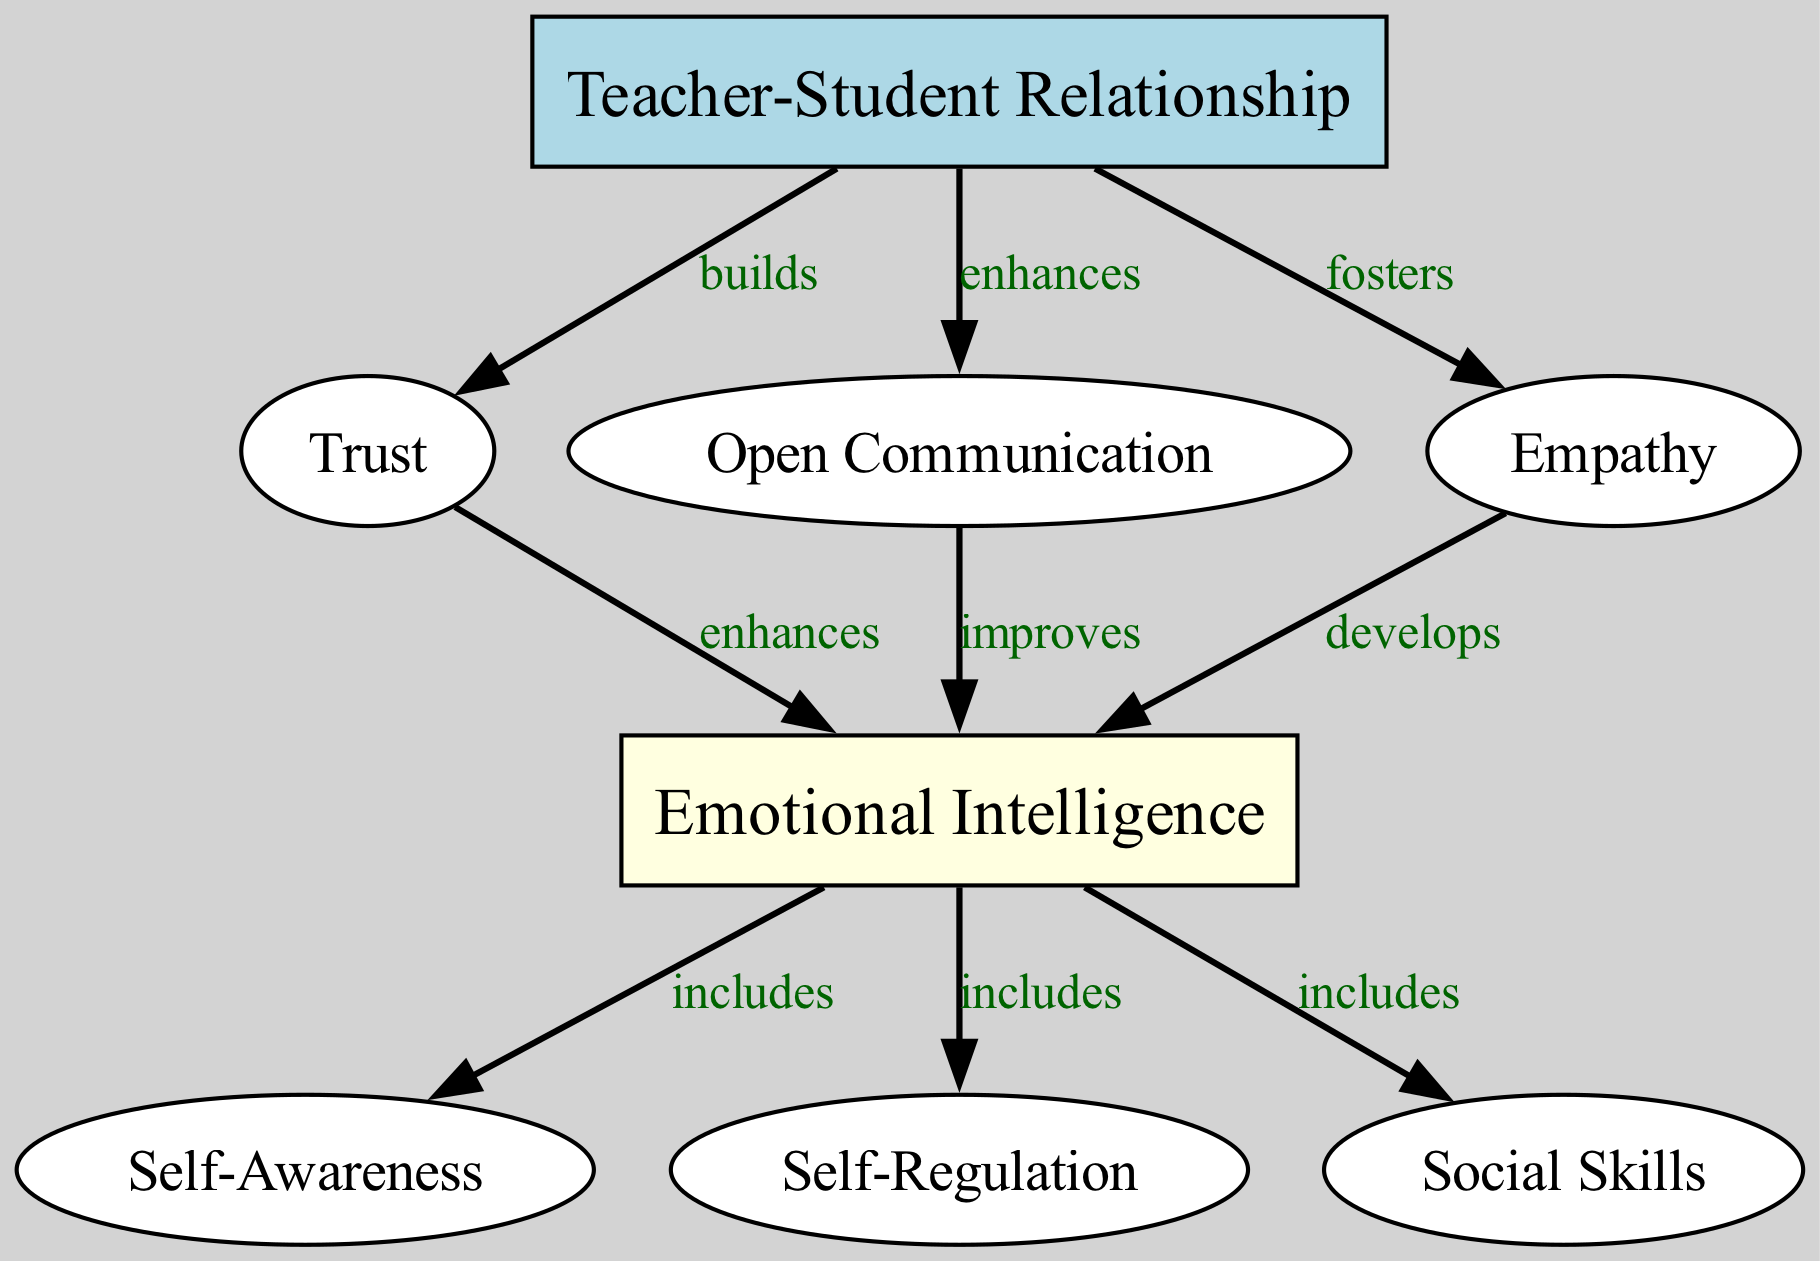What is the main influence depicted in the diagram that affects emotional intelligence? The diagram emphasizes the "Teacher-Student Relationship" as the primary influence since it is the root node, indicating that it is fundamental in fostering emotional intelligence through trust, communication, and empathy.
Answer: Teacher-Student Relationship How many nodes are present in the diagram? Counting all the nodes listed, there are eight distinct nodes displayed: Teacher-Student Relationship, Trust, Open Communication, Empathy, Emotional Intelligence, Self-Awareness, Self-Regulation, and Social Skills.
Answer: 8 Which node directly relates to trust? The node that is connected to trust is "emotional intelligence." The diagram shows that trust enhances emotional intelligence, indicating a direct relationship based on trust.
Answer: Emotional Intelligence What is the relationship between open communication and emotional intelligence? The diagram specifies that open communication "improves" emotional intelligence. This indicates that effective communication is a key factor contributing to better emotional intelligence in students.
Answer: Improves How does the diagram suggest that empathy affects emotional intelligence? According to the diagram, empathy "develops" emotional intelligence, meaning that fostering empathy in teacher-student relationships contributes to the growth of emotional intelligence in students.
Answer: Develops What three skills are included as part of emotional intelligence? The diagram shows that emotional intelligence includes self-awareness, self-regulation, and social skills, highlighting these three specific skills that are integral to emotional intelligence.
Answer: Self-Awareness, Self-Regulation, Social Skills What effect does the teacher-student relationship have on trust? The diagram indicates that the teacher-student relationship "builds" trust, illustrating that strong connections between teachers and students create a foundation of trust.
Answer: Builds Which nodes have a direct connection to emotional intelligence? The diagram illustrates that trust, open communication, and empathy all have direct connections to emotional intelligence, each influencing it positively.
Answer: Trust, Open Communication, Empathy What is the ultimate outcome of the connections between empathy and emotional intelligence as per the diagram? The diagram suggests that empathy significantly contributes to the development of emotional intelligence, indicating that nurturing empathy is crucial for enhancing emotional intelligence outcomes.
Answer: Develops 